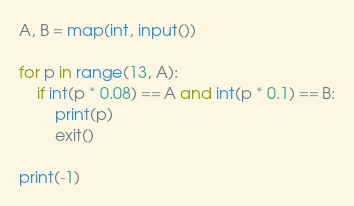<code> <loc_0><loc_0><loc_500><loc_500><_Python_>A, B = map(int, input())

for p in range(13, A):
	if int(p * 0.08) == A and int(p * 0.1) == B:
		print(p)
		exit()

print(-1)
</code> 